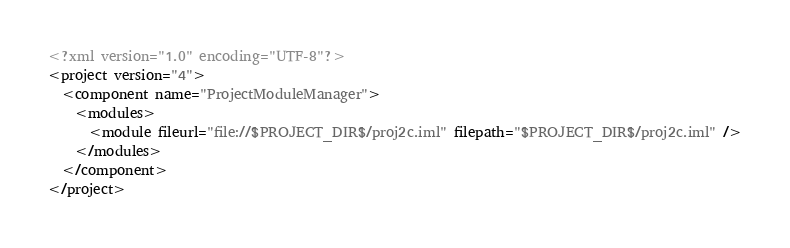Convert code to text. <code><loc_0><loc_0><loc_500><loc_500><_XML_><?xml version="1.0" encoding="UTF-8"?>
<project version="4">
  <component name="ProjectModuleManager">
    <modules>
      <module fileurl="file://$PROJECT_DIR$/proj2c.iml" filepath="$PROJECT_DIR$/proj2c.iml" />
    </modules>
  </component>
</project></code> 